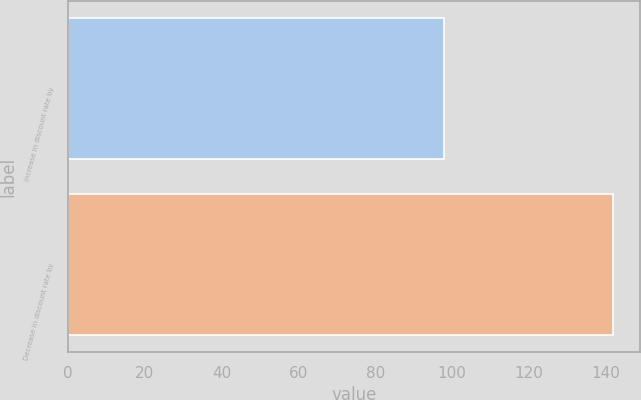<chart> <loc_0><loc_0><loc_500><loc_500><bar_chart><fcel>Increase in discount rate by<fcel>Decrease in discount rate by<nl><fcel>98<fcel>142<nl></chart> 